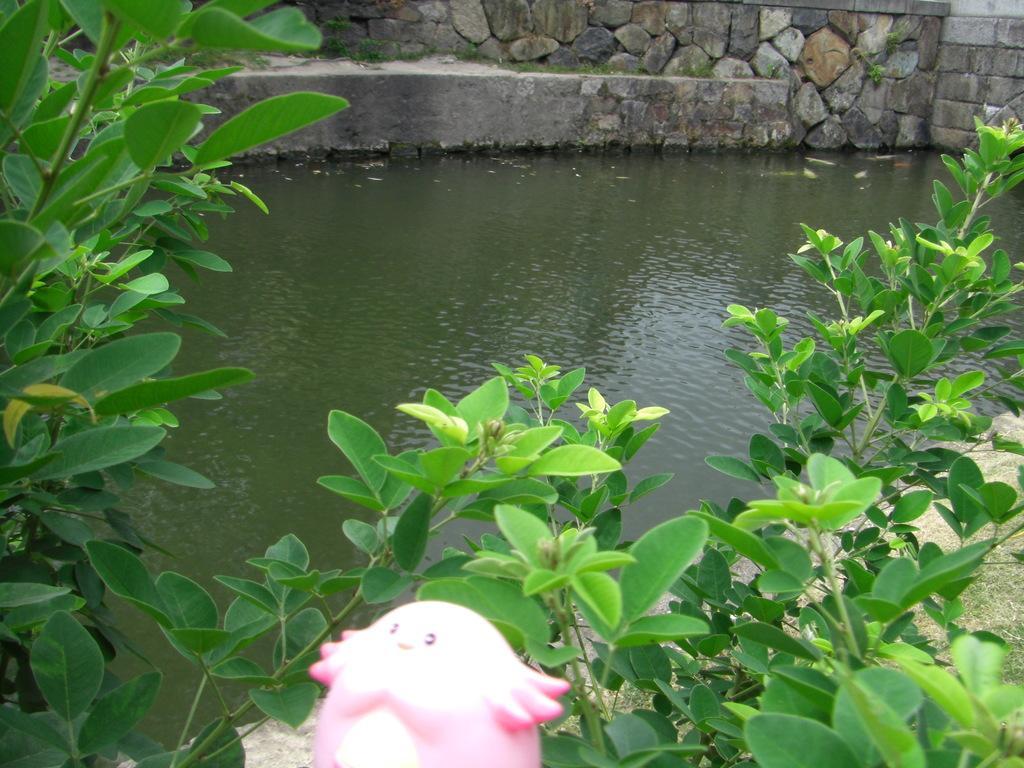In one or two sentences, can you explain what this image depicts? There is water. On the sides there are plants and brick wall. Also there is a pink color toy. 